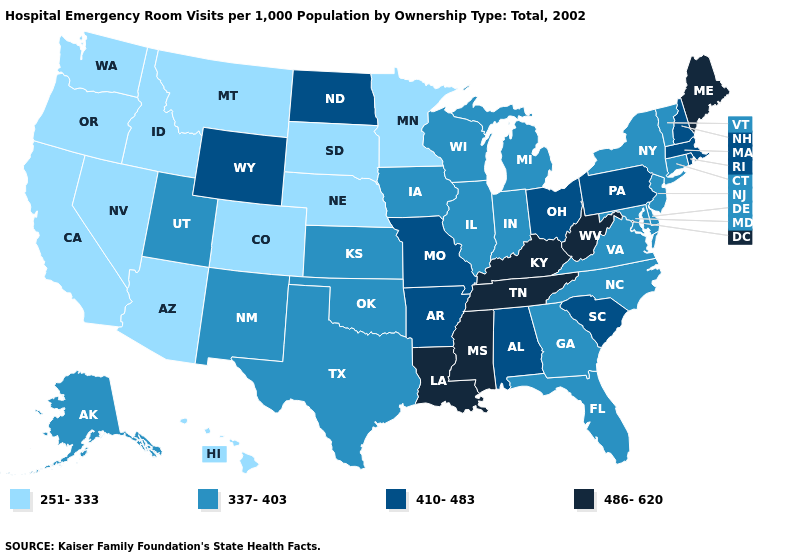What is the value of North Dakota?
Concise answer only. 410-483. Among the states that border New Hampshire , does Massachusetts have the lowest value?
Write a very short answer. No. Which states have the lowest value in the USA?
Answer briefly. Arizona, California, Colorado, Hawaii, Idaho, Minnesota, Montana, Nebraska, Nevada, Oregon, South Dakota, Washington. Does the first symbol in the legend represent the smallest category?
Be succinct. Yes. What is the value of Alaska?
Write a very short answer. 337-403. What is the value of Illinois?
Write a very short answer. 337-403. Which states have the lowest value in the USA?
Be succinct. Arizona, California, Colorado, Hawaii, Idaho, Minnesota, Montana, Nebraska, Nevada, Oregon, South Dakota, Washington. What is the value of Washington?
Be succinct. 251-333. Name the states that have a value in the range 251-333?
Concise answer only. Arizona, California, Colorado, Hawaii, Idaho, Minnesota, Montana, Nebraska, Nevada, Oregon, South Dakota, Washington. Which states hav the highest value in the Northeast?
Give a very brief answer. Maine. Name the states that have a value in the range 251-333?
Short answer required. Arizona, California, Colorado, Hawaii, Idaho, Minnesota, Montana, Nebraska, Nevada, Oregon, South Dakota, Washington. Name the states that have a value in the range 410-483?
Give a very brief answer. Alabama, Arkansas, Massachusetts, Missouri, New Hampshire, North Dakota, Ohio, Pennsylvania, Rhode Island, South Carolina, Wyoming. What is the value of Washington?
Quick response, please. 251-333. What is the highest value in the USA?
Short answer required. 486-620. What is the lowest value in the West?
Quick response, please. 251-333. 